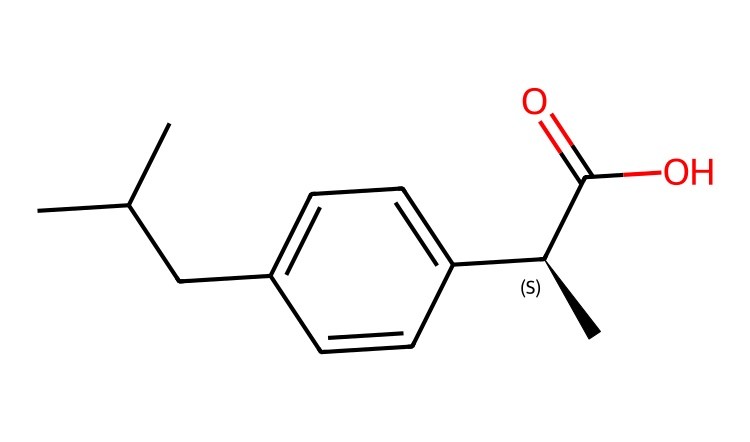What is the molecular formula of ibuprofen? The molecular formula can be identified by counting the different types of atoms in the SMILES representation. The structure contains 13 carbon atoms (C), 18 hydrogen atoms (H), and 2 oxygen atoms (O). Therefore, the molecular formula is C13H18O2.
Answer: C13H18O2 How many rings are present in this structure? Examining the SMILES, there are no cycles or rings as we can see all carbon atoms are part of a linear or branched structure without any closures. Thus, the number of rings is zero.
Answer: zero What is the primary functional group in ibuprofen? The presence of the carboxylic acid group (indicated by the -COOH in the SMILES) is the functional group that characterizes ibuprofen, which is crucial for its anti-inflammatory properties.
Answer: carboxylic acid How many chiral centers does ibuprofen contain? To determine the number of chiral centers, we need to identify carbon atoms that have four different substituents. In the structure, there is one chiral center at the carbon marked with [C@H], which confirms it has three unique attachments. Hence, the number of chiral centers is one.
Answer: one What type of compound is ibuprofen classified as? Ibuprofen is an aliphatic compound because it consists of carbon and hydrogen atoms arranged in open chains without any aromatic or cyclic structures. This is evidenced by its linear components depicted in the SMILES.
Answer: aliphatic 